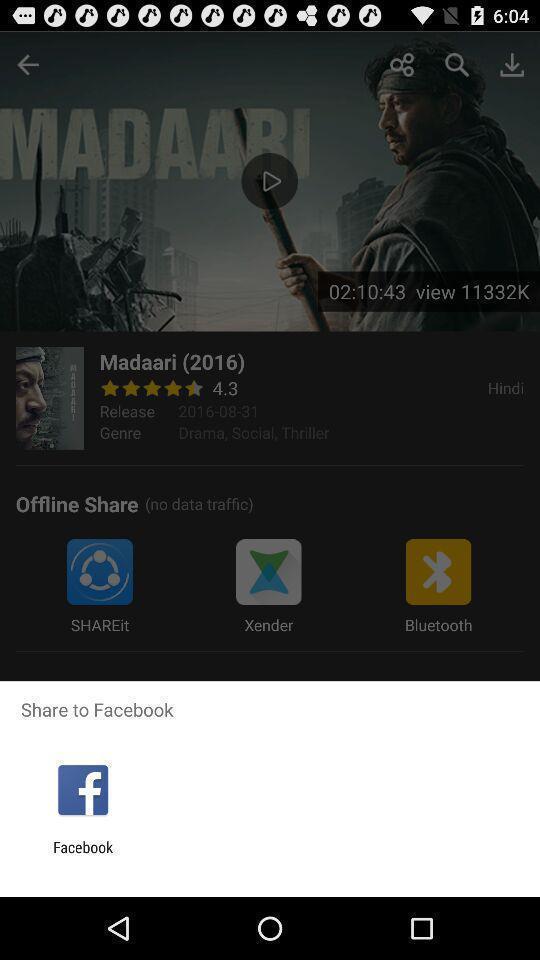Give me a narrative description of this picture. Share information with social media. 